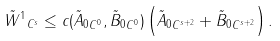Convert formula to latex. <formula><loc_0><loc_0><loc_500><loc_500>\| \tilde { W } ^ { 1 } \| _ { C ^ { s } } \leq c ( \| \tilde { A } _ { 0 } \| _ { C ^ { 0 } } , \| \tilde { B } _ { 0 } \| _ { C ^ { 0 } } ) \left ( \| \tilde { A } _ { 0 } \| _ { C ^ { s + 2 } } + \| \tilde { B } _ { 0 } \| _ { C ^ { s + 2 } } \right ) .</formula> 